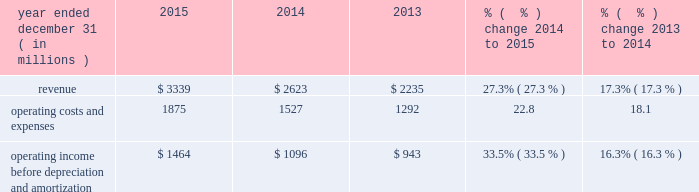Other operating and administrative expenses increased slightly in 2015 due to increased expenses asso- ciated with our larger film slate .
Other operating and administrative expenses increased in 2014 primarily due to the inclusion of fandango , which was previously presented in our cable networks segment .
Advertising , marketing and promotion expenses advertising , marketing and promotion expenses consist primarily of expenses associated with advertising for our theatrical releases and the marketing of our films on dvd and in digital formats .
We incur significant marketing expenses before and throughout the release of a film in movie theaters .
As a result , we typically incur losses on a film prior to and during the film 2019s exhibition in movie theaters and may not realize profits , if any , until the film generates home entertainment and content licensing revenue .
The costs associated with producing and marketing films have generally increased in recent years and may continue to increase in the future .
Advertising , marketing and promotion expenses increased in 2015 primarily due to higher promotional costs associated with our larger 2015 film slate and increased advertising expenses for fandango .
Advertising , marketing and promotion expenses decreased in 2014 primarily due to fewer major film releases compared to theme parks segment results of operations year ended december 31 ( in millions ) 2015 2014 2013 % (  % ) change 2014 to 2015 % (  % ) change 2013 to 2014 .
Operating income before depreciation and amortization $ 1464 $ 1096 $ 943 33.5% ( 33.5 % ) 16.3% ( 16.3 % ) theme parks segment 2013 revenue in 2015 , our theme parks segment revenue was generated primarily from ticket sales and guest spending at our universal theme parks in orlando , florida and hollywood , california , as well as from licensing and other fees .
In november 2015 , nbcuniversal acquired a 51% ( 51 % ) interest in universal studios japan .
Guest spending includes in-park spending on food , beverages and merchandise .
Guest attendance at our theme parks and guest spending depend heavily on the general environment for travel and tourism , including consumer spend- ing on travel and other recreational activities .
Licensing and other fees relate primarily to our agreements with third parties that own and operate the universal studios singapore theme park , as well as from the universal studios japan theme park , to license the right to use the universal studios brand name and other intellectual property .
Theme parks segment revenue increased in 2015 and 2014 primarily due to increases in guest attendance and increases in guest spending at our orlando and hollywood theme parks .
The increase in 2015 was pri- marily due to the continued success of our attractions , including the wizarding world of harry potter 2122 2014 diagon alley 2122 in orlando and the fast & furious 2122 2014 supercharged 2122 studio tour and the simpson 2019s springfield attraction in hollywood , both of which opened in 2015 .
In addition , theme parks segment revenue in 2015 includes $ 169 million of revenue attributable to universal studios japan for the period from november 13 , 2015 to december 31 , 2015 .
The increase in 2014 was primarily due to new attractions , such as the wizarding world of harry potter 2122 2014 diagon alley 2122 in orlando , which opened in july 2014 , and despicable me : minion mayhem in hollywood .
59 comcast 2015 annual report on form 10-k .
What was the operating profit margin for the year of 2015? 
Rationale: operating margin is a measure of the efficiency of on going operations before extraneous expenses of overhead .
Computations: (1464 / 3339)
Answer: 0.43845. 